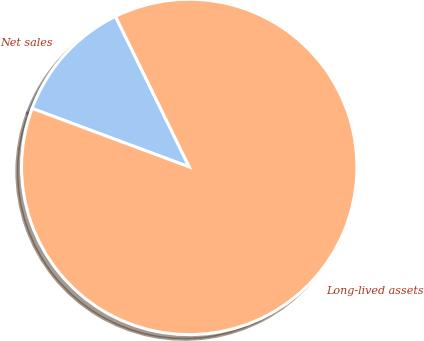<chart> <loc_0><loc_0><loc_500><loc_500><pie_chart><fcel>Net sales<fcel>Long-lived assets<nl><fcel>12.08%<fcel>87.92%<nl></chart> 